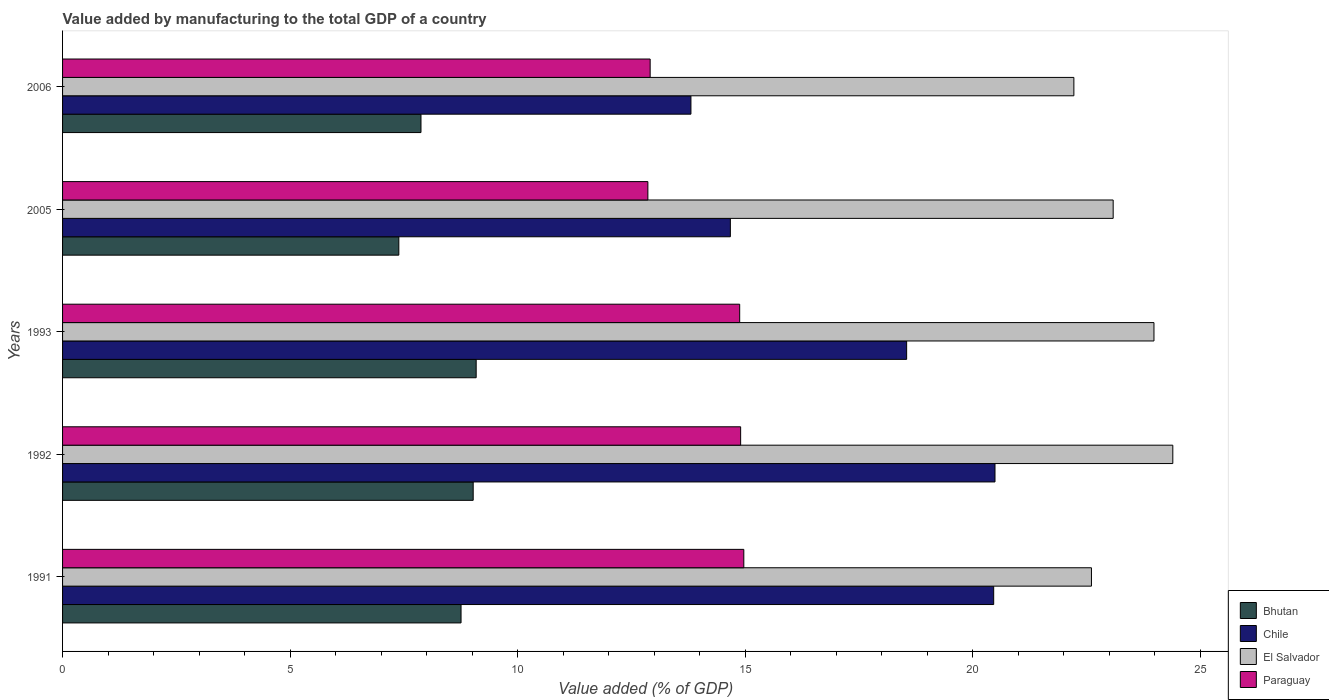How many different coloured bars are there?
Your response must be concise. 4. How many bars are there on the 3rd tick from the top?
Your response must be concise. 4. How many bars are there on the 3rd tick from the bottom?
Provide a succinct answer. 4. What is the label of the 1st group of bars from the top?
Your answer should be compact. 2006. What is the value added by manufacturing to the total GDP in Bhutan in 1992?
Give a very brief answer. 9.02. Across all years, what is the maximum value added by manufacturing to the total GDP in Bhutan?
Provide a succinct answer. 9.09. Across all years, what is the minimum value added by manufacturing to the total GDP in El Salvador?
Offer a terse response. 22.22. In which year was the value added by manufacturing to the total GDP in Bhutan minimum?
Provide a short and direct response. 2005. What is the total value added by manufacturing to the total GDP in Chile in the graph?
Give a very brief answer. 87.98. What is the difference between the value added by manufacturing to the total GDP in Chile in 1991 and that in 2005?
Offer a very short reply. 5.79. What is the difference between the value added by manufacturing to the total GDP in El Salvador in 2005 and the value added by manufacturing to the total GDP in Paraguay in 1991?
Your answer should be compact. 8.12. What is the average value added by manufacturing to the total GDP in Paraguay per year?
Provide a short and direct response. 14.1. In the year 1993, what is the difference between the value added by manufacturing to the total GDP in El Salvador and value added by manufacturing to the total GDP in Chile?
Provide a short and direct response. 5.43. What is the ratio of the value added by manufacturing to the total GDP in Chile in 1991 to that in 1992?
Make the answer very short. 1. Is the difference between the value added by manufacturing to the total GDP in El Salvador in 1992 and 2006 greater than the difference between the value added by manufacturing to the total GDP in Chile in 1992 and 2006?
Your response must be concise. No. What is the difference between the highest and the second highest value added by manufacturing to the total GDP in Chile?
Offer a very short reply. 0.03. What is the difference between the highest and the lowest value added by manufacturing to the total GDP in Chile?
Your answer should be compact. 6.68. In how many years, is the value added by manufacturing to the total GDP in El Salvador greater than the average value added by manufacturing to the total GDP in El Salvador taken over all years?
Your response must be concise. 2. Is the sum of the value added by manufacturing to the total GDP in Paraguay in 1991 and 1993 greater than the maximum value added by manufacturing to the total GDP in Bhutan across all years?
Keep it short and to the point. Yes. What does the 1st bar from the top in 1991 represents?
Keep it short and to the point. Paraguay. What does the 3rd bar from the bottom in 2005 represents?
Your answer should be compact. El Salvador. Are all the bars in the graph horizontal?
Offer a very short reply. Yes. What is the difference between two consecutive major ticks on the X-axis?
Give a very brief answer. 5. Does the graph contain any zero values?
Your answer should be very brief. No. Does the graph contain grids?
Provide a succinct answer. No. Where does the legend appear in the graph?
Your answer should be compact. Bottom right. How are the legend labels stacked?
Make the answer very short. Vertical. What is the title of the graph?
Make the answer very short. Value added by manufacturing to the total GDP of a country. Does "Mali" appear as one of the legend labels in the graph?
Offer a very short reply. No. What is the label or title of the X-axis?
Ensure brevity in your answer.  Value added (% of GDP). What is the label or title of the Y-axis?
Your response must be concise. Years. What is the Value added (% of GDP) of Bhutan in 1991?
Offer a very short reply. 8.76. What is the Value added (% of GDP) of Chile in 1991?
Give a very brief answer. 20.46. What is the Value added (% of GDP) in El Salvador in 1991?
Your answer should be compact. 22.61. What is the Value added (% of GDP) in Paraguay in 1991?
Provide a short and direct response. 14.97. What is the Value added (% of GDP) in Bhutan in 1992?
Make the answer very short. 9.02. What is the Value added (% of GDP) in Chile in 1992?
Provide a short and direct response. 20.49. What is the Value added (% of GDP) in El Salvador in 1992?
Offer a very short reply. 24.4. What is the Value added (% of GDP) of Paraguay in 1992?
Provide a succinct answer. 14.9. What is the Value added (% of GDP) of Bhutan in 1993?
Provide a short and direct response. 9.09. What is the Value added (% of GDP) in Chile in 1993?
Provide a succinct answer. 18.55. What is the Value added (% of GDP) in El Salvador in 1993?
Your answer should be compact. 23.98. What is the Value added (% of GDP) in Paraguay in 1993?
Your response must be concise. 14.88. What is the Value added (% of GDP) in Bhutan in 2005?
Make the answer very short. 7.39. What is the Value added (% of GDP) of Chile in 2005?
Offer a terse response. 14.67. What is the Value added (% of GDP) of El Salvador in 2005?
Offer a terse response. 23.09. What is the Value added (% of GDP) in Paraguay in 2005?
Keep it short and to the point. 12.86. What is the Value added (% of GDP) of Bhutan in 2006?
Provide a succinct answer. 7.88. What is the Value added (% of GDP) of Chile in 2006?
Offer a very short reply. 13.81. What is the Value added (% of GDP) of El Salvador in 2006?
Offer a terse response. 22.22. What is the Value added (% of GDP) in Paraguay in 2006?
Keep it short and to the point. 12.91. Across all years, what is the maximum Value added (% of GDP) in Bhutan?
Your answer should be compact. 9.09. Across all years, what is the maximum Value added (% of GDP) of Chile?
Your answer should be very brief. 20.49. Across all years, what is the maximum Value added (% of GDP) in El Salvador?
Your answer should be compact. 24.4. Across all years, what is the maximum Value added (% of GDP) of Paraguay?
Ensure brevity in your answer.  14.97. Across all years, what is the minimum Value added (% of GDP) of Bhutan?
Provide a short and direct response. 7.39. Across all years, what is the minimum Value added (% of GDP) in Chile?
Offer a very short reply. 13.81. Across all years, what is the minimum Value added (% of GDP) in El Salvador?
Give a very brief answer. 22.22. Across all years, what is the minimum Value added (% of GDP) of Paraguay?
Your answer should be compact. 12.86. What is the total Value added (% of GDP) in Bhutan in the graph?
Keep it short and to the point. 42.13. What is the total Value added (% of GDP) in Chile in the graph?
Your response must be concise. 87.98. What is the total Value added (% of GDP) of El Salvador in the graph?
Keep it short and to the point. 116.29. What is the total Value added (% of GDP) in Paraguay in the graph?
Provide a succinct answer. 70.52. What is the difference between the Value added (% of GDP) in Bhutan in 1991 and that in 1992?
Give a very brief answer. -0.27. What is the difference between the Value added (% of GDP) of Chile in 1991 and that in 1992?
Provide a short and direct response. -0.03. What is the difference between the Value added (% of GDP) in El Salvador in 1991 and that in 1992?
Ensure brevity in your answer.  -1.79. What is the difference between the Value added (% of GDP) in Paraguay in 1991 and that in 1992?
Offer a terse response. 0.07. What is the difference between the Value added (% of GDP) in Bhutan in 1991 and that in 1993?
Offer a terse response. -0.33. What is the difference between the Value added (% of GDP) in Chile in 1991 and that in 1993?
Your answer should be compact. 1.91. What is the difference between the Value added (% of GDP) of El Salvador in 1991 and that in 1993?
Keep it short and to the point. -1.37. What is the difference between the Value added (% of GDP) of Paraguay in 1991 and that in 1993?
Give a very brief answer. 0.09. What is the difference between the Value added (% of GDP) of Bhutan in 1991 and that in 2005?
Your answer should be compact. 1.37. What is the difference between the Value added (% of GDP) of Chile in 1991 and that in 2005?
Offer a very short reply. 5.79. What is the difference between the Value added (% of GDP) in El Salvador in 1991 and that in 2005?
Your answer should be very brief. -0.48. What is the difference between the Value added (% of GDP) of Paraguay in 1991 and that in 2005?
Give a very brief answer. 2.11. What is the difference between the Value added (% of GDP) of Bhutan in 1991 and that in 2006?
Provide a succinct answer. 0.88. What is the difference between the Value added (% of GDP) in Chile in 1991 and that in 2006?
Provide a succinct answer. 6.65. What is the difference between the Value added (% of GDP) in El Salvador in 1991 and that in 2006?
Your answer should be very brief. 0.39. What is the difference between the Value added (% of GDP) in Paraguay in 1991 and that in 2006?
Provide a short and direct response. 2.06. What is the difference between the Value added (% of GDP) of Bhutan in 1992 and that in 1993?
Make the answer very short. -0.07. What is the difference between the Value added (% of GDP) of Chile in 1992 and that in 1993?
Offer a terse response. 1.94. What is the difference between the Value added (% of GDP) in El Salvador in 1992 and that in 1993?
Your answer should be very brief. 0.41. What is the difference between the Value added (% of GDP) of Paraguay in 1992 and that in 1993?
Make the answer very short. 0.02. What is the difference between the Value added (% of GDP) in Bhutan in 1992 and that in 2005?
Make the answer very short. 1.63. What is the difference between the Value added (% of GDP) of Chile in 1992 and that in 2005?
Give a very brief answer. 5.81. What is the difference between the Value added (% of GDP) of El Salvador in 1992 and that in 2005?
Give a very brief answer. 1.31. What is the difference between the Value added (% of GDP) in Paraguay in 1992 and that in 2005?
Provide a succinct answer. 2.04. What is the difference between the Value added (% of GDP) in Bhutan in 1992 and that in 2006?
Ensure brevity in your answer.  1.15. What is the difference between the Value added (% of GDP) in Chile in 1992 and that in 2006?
Provide a succinct answer. 6.68. What is the difference between the Value added (% of GDP) in El Salvador in 1992 and that in 2006?
Offer a terse response. 2.17. What is the difference between the Value added (% of GDP) of Paraguay in 1992 and that in 2006?
Offer a very short reply. 1.99. What is the difference between the Value added (% of GDP) of Bhutan in 1993 and that in 2005?
Keep it short and to the point. 1.7. What is the difference between the Value added (% of GDP) in Chile in 1993 and that in 2005?
Keep it short and to the point. 3.87. What is the difference between the Value added (% of GDP) of El Salvador in 1993 and that in 2005?
Offer a terse response. 0.9. What is the difference between the Value added (% of GDP) of Paraguay in 1993 and that in 2005?
Offer a very short reply. 2.02. What is the difference between the Value added (% of GDP) of Bhutan in 1993 and that in 2006?
Keep it short and to the point. 1.21. What is the difference between the Value added (% of GDP) of Chile in 1993 and that in 2006?
Your answer should be compact. 4.74. What is the difference between the Value added (% of GDP) in El Salvador in 1993 and that in 2006?
Make the answer very short. 1.76. What is the difference between the Value added (% of GDP) in Paraguay in 1993 and that in 2006?
Offer a very short reply. 1.97. What is the difference between the Value added (% of GDP) of Bhutan in 2005 and that in 2006?
Make the answer very short. -0.49. What is the difference between the Value added (% of GDP) of Chile in 2005 and that in 2006?
Your response must be concise. 0.87. What is the difference between the Value added (% of GDP) in El Salvador in 2005 and that in 2006?
Offer a very short reply. 0.86. What is the difference between the Value added (% of GDP) of Paraguay in 2005 and that in 2006?
Your response must be concise. -0.05. What is the difference between the Value added (% of GDP) in Bhutan in 1991 and the Value added (% of GDP) in Chile in 1992?
Offer a very short reply. -11.73. What is the difference between the Value added (% of GDP) of Bhutan in 1991 and the Value added (% of GDP) of El Salvador in 1992?
Your answer should be very brief. -15.64. What is the difference between the Value added (% of GDP) of Bhutan in 1991 and the Value added (% of GDP) of Paraguay in 1992?
Give a very brief answer. -6.14. What is the difference between the Value added (% of GDP) of Chile in 1991 and the Value added (% of GDP) of El Salvador in 1992?
Offer a very short reply. -3.94. What is the difference between the Value added (% of GDP) of Chile in 1991 and the Value added (% of GDP) of Paraguay in 1992?
Provide a short and direct response. 5.56. What is the difference between the Value added (% of GDP) of El Salvador in 1991 and the Value added (% of GDP) of Paraguay in 1992?
Your answer should be very brief. 7.71. What is the difference between the Value added (% of GDP) of Bhutan in 1991 and the Value added (% of GDP) of Chile in 1993?
Your response must be concise. -9.79. What is the difference between the Value added (% of GDP) in Bhutan in 1991 and the Value added (% of GDP) in El Salvador in 1993?
Keep it short and to the point. -15.23. What is the difference between the Value added (% of GDP) of Bhutan in 1991 and the Value added (% of GDP) of Paraguay in 1993?
Your answer should be compact. -6.12. What is the difference between the Value added (% of GDP) of Chile in 1991 and the Value added (% of GDP) of El Salvador in 1993?
Your response must be concise. -3.52. What is the difference between the Value added (% of GDP) in Chile in 1991 and the Value added (% of GDP) in Paraguay in 1993?
Provide a short and direct response. 5.58. What is the difference between the Value added (% of GDP) in El Salvador in 1991 and the Value added (% of GDP) in Paraguay in 1993?
Keep it short and to the point. 7.73. What is the difference between the Value added (% of GDP) of Bhutan in 1991 and the Value added (% of GDP) of Chile in 2005?
Give a very brief answer. -5.92. What is the difference between the Value added (% of GDP) of Bhutan in 1991 and the Value added (% of GDP) of El Salvador in 2005?
Ensure brevity in your answer.  -14.33. What is the difference between the Value added (% of GDP) of Bhutan in 1991 and the Value added (% of GDP) of Paraguay in 2005?
Ensure brevity in your answer.  -4.11. What is the difference between the Value added (% of GDP) of Chile in 1991 and the Value added (% of GDP) of El Salvador in 2005?
Your response must be concise. -2.63. What is the difference between the Value added (% of GDP) of Chile in 1991 and the Value added (% of GDP) of Paraguay in 2005?
Provide a succinct answer. 7.6. What is the difference between the Value added (% of GDP) of El Salvador in 1991 and the Value added (% of GDP) of Paraguay in 2005?
Provide a short and direct response. 9.75. What is the difference between the Value added (% of GDP) of Bhutan in 1991 and the Value added (% of GDP) of Chile in 2006?
Make the answer very short. -5.05. What is the difference between the Value added (% of GDP) in Bhutan in 1991 and the Value added (% of GDP) in El Salvador in 2006?
Provide a succinct answer. -13.47. What is the difference between the Value added (% of GDP) of Bhutan in 1991 and the Value added (% of GDP) of Paraguay in 2006?
Offer a very short reply. -4.16. What is the difference between the Value added (% of GDP) of Chile in 1991 and the Value added (% of GDP) of El Salvador in 2006?
Your answer should be compact. -1.76. What is the difference between the Value added (% of GDP) of Chile in 1991 and the Value added (% of GDP) of Paraguay in 2006?
Your response must be concise. 7.55. What is the difference between the Value added (% of GDP) of El Salvador in 1991 and the Value added (% of GDP) of Paraguay in 2006?
Your answer should be compact. 9.7. What is the difference between the Value added (% of GDP) in Bhutan in 1992 and the Value added (% of GDP) in Chile in 1993?
Keep it short and to the point. -9.52. What is the difference between the Value added (% of GDP) of Bhutan in 1992 and the Value added (% of GDP) of El Salvador in 1993?
Offer a very short reply. -14.96. What is the difference between the Value added (% of GDP) of Bhutan in 1992 and the Value added (% of GDP) of Paraguay in 1993?
Keep it short and to the point. -5.86. What is the difference between the Value added (% of GDP) of Chile in 1992 and the Value added (% of GDP) of El Salvador in 1993?
Provide a short and direct response. -3.49. What is the difference between the Value added (% of GDP) in Chile in 1992 and the Value added (% of GDP) in Paraguay in 1993?
Your answer should be compact. 5.61. What is the difference between the Value added (% of GDP) in El Salvador in 1992 and the Value added (% of GDP) in Paraguay in 1993?
Offer a terse response. 9.52. What is the difference between the Value added (% of GDP) of Bhutan in 1992 and the Value added (% of GDP) of Chile in 2005?
Your answer should be very brief. -5.65. What is the difference between the Value added (% of GDP) in Bhutan in 1992 and the Value added (% of GDP) in El Salvador in 2005?
Your answer should be compact. -14.06. What is the difference between the Value added (% of GDP) in Bhutan in 1992 and the Value added (% of GDP) in Paraguay in 2005?
Ensure brevity in your answer.  -3.84. What is the difference between the Value added (% of GDP) of Chile in 1992 and the Value added (% of GDP) of El Salvador in 2005?
Offer a very short reply. -2.6. What is the difference between the Value added (% of GDP) of Chile in 1992 and the Value added (% of GDP) of Paraguay in 2005?
Ensure brevity in your answer.  7.63. What is the difference between the Value added (% of GDP) in El Salvador in 1992 and the Value added (% of GDP) in Paraguay in 2005?
Offer a terse response. 11.53. What is the difference between the Value added (% of GDP) in Bhutan in 1992 and the Value added (% of GDP) in Chile in 2006?
Offer a very short reply. -4.78. What is the difference between the Value added (% of GDP) of Bhutan in 1992 and the Value added (% of GDP) of El Salvador in 2006?
Offer a very short reply. -13.2. What is the difference between the Value added (% of GDP) of Bhutan in 1992 and the Value added (% of GDP) of Paraguay in 2006?
Provide a succinct answer. -3.89. What is the difference between the Value added (% of GDP) of Chile in 1992 and the Value added (% of GDP) of El Salvador in 2006?
Your response must be concise. -1.73. What is the difference between the Value added (% of GDP) of Chile in 1992 and the Value added (% of GDP) of Paraguay in 2006?
Your response must be concise. 7.58. What is the difference between the Value added (% of GDP) of El Salvador in 1992 and the Value added (% of GDP) of Paraguay in 2006?
Offer a very short reply. 11.48. What is the difference between the Value added (% of GDP) of Bhutan in 1993 and the Value added (% of GDP) of Chile in 2005?
Keep it short and to the point. -5.59. What is the difference between the Value added (% of GDP) in Bhutan in 1993 and the Value added (% of GDP) in El Salvador in 2005?
Your answer should be very brief. -14. What is the difference between the Value added (% of GDP) in Bhutan in 1993 and the Value added (% of GDP) in Paraguay in 2005?
Make the answer very short. -3.77. What is the difference between the Value added (% of GDP) in Chile in 1993 and the Value added (% of GDP) in El Salvador in 2005?
Give a very brief answer. -4.54. What is the difference between the Value added (% of GDP) in Chile in 1993 and the Value added (% of GDP) in Paraguay in 2005?
Offer a terse response. 5.69. What is the difference between the Value added (% of GDP) of El Salvador in 1993 and the Value added (% of GDP) of Paraguay in 2005?
Give a very brief answer. 11.12. What is the difference between the Value added (% of GDP) in Bhutan in 1993 and the Value added (% of GDP) in Chile in 2006?
Provide a succinct answer. -4.72. What is the difference between the Value added (% of GDP) in Bhutan in 1993 and the Value added (% of GDP) in El Salvador in 2006?
Your answer should be compact. -13.13. What is the difference between the Value added (% of GDP) of Bhutan in 1993 and the Value added (% of GDP) of Paraguay in 2006?
Provide a succinct answer. -3.82. What is the difference between the Value added (% of GDP) in Chile in 1993 and the Value added (% of GDP) in El Salvador in 2006?
Make the answer very short. -3.67. What is the difference between the Value added (% of GDP) in Chile in 1993 and the Value added (% of GDP) in Paraguay in 2006?
Your answer should be very brief. 5.64. What is the difference between the Value added (% of GDP) of El Salvador in 1993 and the Value added (% of GDP) of Paraguay in 2006?
Offer a terse response. 11.07. What is the difference between the Value added (% of GDP) in Bhutan in 2005 and the Value added (% of GDP) in Chile in 2006?
Your answer should be compact. -6.42. What is the difference between the Value added (% of GDP) of Bhutan in 2005 and the Value added (% of GDP) of El Salvador in 2006?
Give a very brief answer. -14.83. What is the difference between the Value added (% of GDP) of Bhutan in 2005 and the Value added (% of GDP) of Paraguay in 2006?
Your answer should be very brief. -5.52. What is the difference between the Value added (% of GDP) in Chile in 2005 and the Value added (% of GDP) in El Salvador in 2006?
Offer a terse response. -7.55. What is the difference between the Value added (% of GDP) in Chile in 2005 and the Value added (% of GDP) in Paraguay in 2006?
Your response must be concise. 1.76. What is the difference between the Value added (% of GDP) of El Salvador in 2005 and the Value added (% of GDP) of Paraguay in 2006?
Keep it short and to the point. 10.17. What is the average Value added (% of GDP) in Bhutan per year?
Ensure brevity in your answer.  8.43. What is the average Value added (% of GDP) of Chile per year?
Provide a succinct answer. 17.6. What is the average Value added (% of GDP) in El Salvador per year?
Make the answer very short. 23.26. What is the average Value added (% of GDP) in Paraguay per year?
Your answer should be very brief. 14.1. In the year 1991, what is the difference between the Value added (% of GDP) in Bhutan and Value added (% of GDP) in Chile?
Provide a succinct answer. -11.7. In the year 1991, what is the difference between the Value added (% of GDP) in Bhutan and Value added (% of GDP) in El Salvador?
Keep it short and to the point. -13.85. In the year 1991, what is the difference between the Value added (% of GDP) in Bhutan and Value added (% of GDP) in Paraguay?
Provide a short and direct response. -6.21. In the year 1991, what is the difference between the Value added (% of GDP) of Chile and Value added (% of GDP) of El Salvador?
Your answer should be very brief. -2.15. In the year 1991, what is the difference between the Value added (% of GDP) of Chile and Value added (% of GDP) of Paraguay?
Your answer should be compact. 5.49. In the year 1991, what is the difference between the Value added (% of GDP) in El Salvador and Value added (% of GDP) in Paraguay?
Your answer should be compact. 7.64. In the year 1992, what is the difference between the Value added (% of GDP) in Bhutan and Value added (% of GDP) in Chile?
Provide a succinct answer. -11.47. In the year 1992, what is the difference between the Value added (% of GDP) of Bhutan and Value added (% of GDP) of El Salvador?
Provide a succinct answer. -15.37. In the year 1992, what is the difference between the Value added (% of GDP) in Bhutan and Value added (% of GDP) in Paraguay?
Your answer should be very brief. -5.88. In the year 1992, what is the difference between the Value added (% of GDP) in Chile and Value added (% of GDP) in El Salvador?
Offer a terse response. -3.91. In the year 1992, what is the difference between the Value added (% of GDP) in Chile and Value added (% of GDP) in Paraguay?
Your answer should be very brief. 5.59. In the year 1992, what is the difference between the Value added (% of GDP) of El Salvador and Value added (% of GDP) of Paraguay?
Offer a very short reply. 9.5. In the year 1993, what is the difference between the Value added (% of GDP) in Bhutan and Value added (% of GDP) in Chile?
Give a very brief answer. -9.46. In the year 1993, what is the difference between the Value added (% of GDP) of Bhutan and Value added (% of GDP) of El Salvador?
Make the answer very short. -14.89. In the year 1993, what is the difference between the Value added (% of GDP) of Bhutan and Value added (% of GDP) of Paraguay?
Give a very brief answer. -5.79. In the year 1993, what is the difference between the Value added (% of GDP) of Chile and Value added (% of GDP) of El Salvador?
Give a very brief answer. -5.43. In the year 1993, what is the difference between the Value added (% of GDP) in Chile and Value added (% of GDP) in Paraguay?
Provide a short and direct response. 3.67. In the year 1993, what is the difference between the Value added (% of GDP) of El Salvador and Value added (% of GDP) of Paraguay?
Make the answer very short. 9.1. In the year 2005, what is the difference between the Value added (% of GDP) of Bhutan and Value added (% of GDP) of Chile?
Your answer should be very brief. -7.28. In the year 2005, what is the difference between the Value added (% of GDP) in Bhutan and Value added (% of GDP) in El Salvador?
Your answer should be compact. -15.7. In the year 2005, what is the difference between the Value added (% of GDP) in Bhutan and Value added (% of GDP) in Paraguay?
Provide a short and direct response. -5.47. In the year 2005, what is the difference between the Value added (% of GDP) of Chile and Value added (% of GDP) of El Salvador?
Offer a very short reply. -8.41. In the year 2005, what is the difference between the Value added (% of GDP) of Chile and Value added (% of GDP) of Paraguay?
Ensure brevity in your answer.  1.81. In the year 2005, what is the difference between the Value added (% of GDP) in El Salvador and Value added (% of GDP) in Paraguay?
Your answer should be very brief. 10.22. In the year 2006, what is the difference between the Value added (% of GDP) in Bhutan and Value added (% of GDP) in Chile?
Provide a succinct answer. -5.93. In the year 2006, what is the difference between the Value added (% of GDP) of Bhutan and Value added (% of GDP) of El Salvador?
Your answer should be very brief. -14.35. In the year 2006, what is the difference between the Value added (% of GDP) of Bhutan and Value added (% of GDP) of Paraguay?
Give a very brief answer. -5.04. In the year 2006, what is the difference between the Value added (% of GDP) in Chile and Value added (% of GDP) in El Salvador?
Your answer should be very brief. -8.41. In the year 2006, what is the difference between the Value added (% of GDP) in Chile and Value added (% of GDP) in Paraguay?
Give a very brief answer. 0.9. In the year 2006, what is the difference between the Value added (% of GDP) of El Salvador and Value added (% of GDP) of Paraguay?
Offer a very short reply. 9.31. What is the ratio of the Value added (% of GDP) in Bhutan in 1991 to that in 1992?
Your answer should be compact. 0.97. What is the ratio of the Value added (% of GDP) of El Salvador in 1991 to that in 1992?
Your response must be concise. 0.93. What is the ratio of the Value added (% of GDP) in Bhutan in 1991 to that in 1993?
Keep it short and to the point. 0.96. What is the ratio of the Value added (% of GDP) in Chile in 1991 to that in 1993?
Your answer should be compact. 1.1. What is the ratio of the Value added (% of GDP) in El Salvador in 1991 to that in 1993?
Offer a terse response. 0.94. What is the ratio of the Value added (% of GDP) of Bhutan in 1991 to that in 2005?
Provide a short and direct response. 1.19. What is the ratio of the Value added (% of GDP) in Chile in 1991 to that in 2005?
Provide a succinct answer. 1.39. What is the ratio of the Value added (% of GDP) in El Salvador in 1991 to that in 2005?
Give a very brief answer. 0.98. What is the ratio of the Value added (% of GDP) in Paraguay in 1991 to that in 2005?
Provide a succinct answer. 1.16. What is the ratio of the Value added (% of GDP) of Bhutan in 1991 to that in 2006?
Make the answer very short. 1.11. What is the ratio of the Value added (% of GDP) of Chile in 1991 to that in 2006?
Your answer should be compact. 1.48. What is the ratio of the Value added (% of GDP) in El Salvador in 1991 to that in 2006?
Your answer should be compact. 1.02. What is the ratio of the Value added (% of GDP) in Paraguay in 1991 to that in 2006?
Your response must be concise. 1.16. What is the ratio of the Value added (% of GDP) in Chile in 1992 to that in 1993?
Keep it short and to the point. 1.1. What is the ratio of the Value added (% of GDP) of El Salvador in 1992 to that in 1993?
Ensure brevity in your answer.  1.02. What is the ratio of the Value added (% of GDP) of Paraguay in 1992 to that in 1993?
Provide a short and direct response. 1. What is the ratio of the Value added (% of GDP) in Bhutan in 1992 to that in 2005?
Offer a very short reply. 1.22. What is the ratio of the Value added (% of GDP) in Chile in 1992 to that in 2005?
Provide a succinct answer. 1.4. What is the ratio of the Value added (% of GDP) of El Salvador in 1992 to that in 2005?
Keep it short and to the point. 1.06. What is the ratio of the Value added (% of GDP) in Paraguay in 1992 to that in 2005?
Offer a very short reply. 1.16. What is the ratio of the Value added (% of GDP) of Bhutan in 1992 to that in 2006?
Ensure brevity in your answer.  1.15. What is the ratio of the Value added (% of GDP) of Chile in 1992 to that in 2006?
Your answer should be compact. 1.48. What is the ratio of the Value added (% of GDP) in El Salvador in 1992 to that in 2006?
Ensure brevity in your answer.  1.1. What is the ratio of the Value added (% of GDP) in Paraguay in 1992 to that in 2006?
Your answer should be very brief. 1.15. What is the ratio of the Value added (% of GDP) of Bhutan in 1993 to that in 2005?
Provide a succinct answer. 1.23. What is the ratio of the Value added (% of GDP) of Chile in 1993 to that in 2005?
Ensure brevity in your answer.  1.26. What is the ratio of the Value added (% of GDP) of El Salvador in 1993 to that in 2005?
Your answer should be very brief. 1.04. What is the ratio of the Value added (% of GDP) in Paraguay in 1993 to that in 2005?
Offer a very short reply. 1.16. What is the ratio of the Value added (% of GDP) of Bhutan in 1993 to that in 2006?
Provide a succinct answer. 1.15. What is the ratio of the Value added (% of GDP) in Chile in 1993 to that in 2006?
Your answer should be very brief. 1.34. What is the ratio of the Value added (% of GDP) of El Salvador in 1993 to that in 2006?
Provide a succinct answer. 1.08. What is the ratio of the Value added (% of GDP) in Paraguay in 1993 to that in 2006?
Make the answer very short. 1.15. What is the ratio of the Value added (% of GDP) of Bhutan in 2005 to that in 2006?
Your answer should be very brief. 0.94. What is the ratio of the Value added (% of GDP) of Chile in 2005 to that in 2006?
Your answer should be compact. 1.06. What is the ratio of the Value added (% of GDP) of El Salvador in 2005 to that in 2006?
Provide a succinct answer. 1.04. What is the difference between the highest and the second highest Value added (% of GDP) in Bhutan?
Provide a succinct answer. 0.07. What is the difference between the highest and the second highest Value added (% of GDP) in Chile?
Keep it short and to the point. 0.03. What is the difference between the highest and the second highest Value added (% of GDP) in El Salvador?
Keep it short and to the point. 0.41. What is the difference between the highest and the second highest Value added (% of GDP) of Paraguay?
Your answer should be compact. 0.07. What is the difference between the highest and the lowest Value added (% of GDP) of Bhutan?
Provide a short and direct response. 1.7. What is the difference between the highest and the lowest Value added (% of GDP) in Chile?
Ensure brevity in your answer.  6.68. What is the difference between the highest and the lowest Value added (% of GDP) of El Salvador?
Keep it short and to the point. 2.17. What is the difference between the highest and the lowest Value added (% of GDP) of Paraguay?
Give a very brief answer. 2.11. 